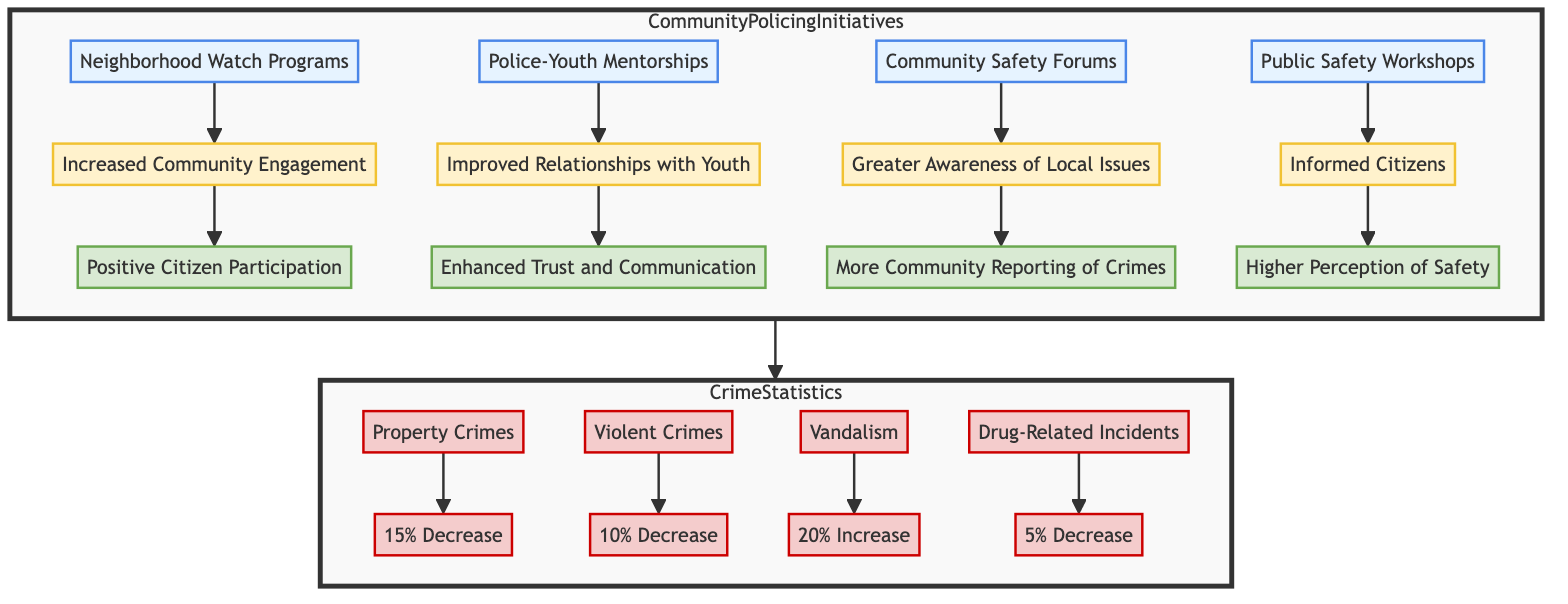What is the outcome of the Neighborhood Watch Programs? The diagram indicates that the outcome of the Neighborhood Watch Programs is "Increased Community Engagement."
Answer: Increased Community Engagement How many Community Policing Initiatives are listed? There are four initiatives displayed in the diagram: Neighborhood Watch Programs, Police-Youth Mentorships, Community Safety Forums, and Public Safety Workshops.
Answer: 4 What is the feedback from the Community Safety Forums? According to the diagram, the feedback from the Community Safety Forums is "More Community Reporting of Crimes."
Answer: More Community Reporting of Crimes What is the statistic for Property Crimes? The diagram shows that there is a "15% Decrease Over Last Year" for Property Crimes.
Answer: 15% Decrease Over Last Year Which initiative corresponds to "Enhanced Trust and Communication"? The Police-Youth Mentorships initiative is linked to the outcome of "Improved Relationships with Youth," which translates into the feedback of "Enhanced Trust and Communication."
Answer: Police-Youth Mentorships What is the relationship between the outcomes and citizen feedback? Each initiative connects to its respective outcome, which in turn is related to citizen feedback; this chain illustrates how community initiatives lead to specific outcomes, reflecting citizen perceptions and engagement.
Answer: Citizens' perceptions What is the overall trend in Drug-Related Incidents? The diagram illustrates that there is a "5% Decrease Over Last Year" in Drug-Related Incidents.
Answer: 5% Decrease Over Last Year Which initiative resulted in a "Higher Perception of Safety"? The Public Safety Workshops initiative resulted in the outcome that includes the feedback "Higher Perception of Safety."
Answer: Public Safety Workshops What is the only crime type with an increase in the statistics? The Vandalism statistic shows a "20% Increase Over Last Year."
Answer: Vandalism What type of flow chart is depicted in this diagram? The diagram represents a "Bottom Up Flow Chart," showcasing community initiatives leading to outcomes and linked to crime statistics.
Answer: Bottom Up Flow Chart 